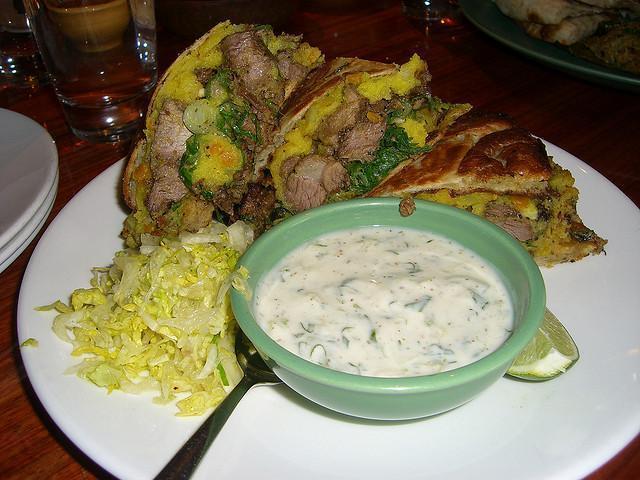How many sandwiches can be seen?
Give a very brief answer. 2. 